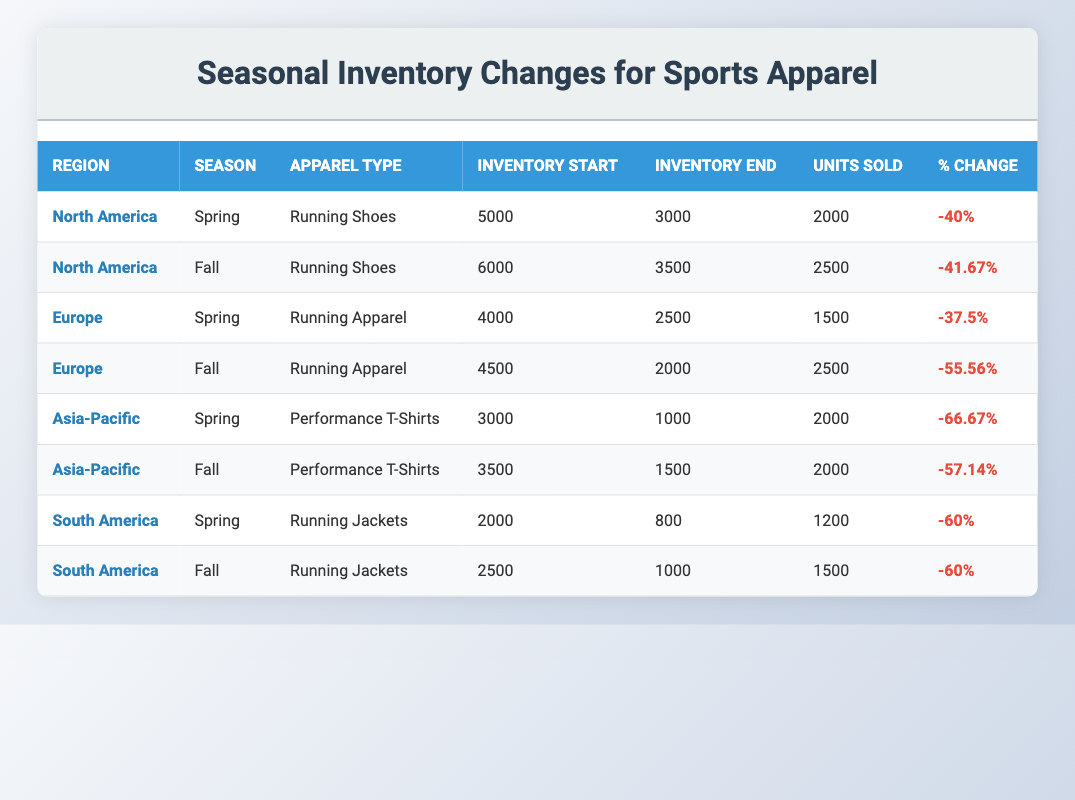What was the inventory start for Running Shoes in North America during Spring? The table lists the inventory start for Running Shoes in North America during Spring as 5000 units.
Answer: 5000 What is the percentage change for Running Apparel in Europe during Fall? According to the table, the percentage change for Running Apparel in Europe during Fall is -55.56%.
Answer: -55.56% In which region and season did Performance T-Shirts have the highest percentage change? By examining the table, Performance T-Shirts had the highest percentage change of -66.67% in the Asia-Pacific region during Spring.
Answer: Asia-Pacific, Spring What were the total units sold for Running Jackets in South America across both seasons? The units sold for Running Jackets were 1200 in Spring and 1500 in Fall. Adding these gives a total of 1200 + 1500 = 2700 units sold.
Answer: 2700 Was there an increase in inventory for any apparel type across the seasons listed? Upon reviewing the table, there are no instances of an increase in inventory for any apparel type; all entries show a decrease in inventory.
Answer: No What region had the most units sold for Running Shoes, and how many units were they? The table shows that North America had the most units sold for Running Shoes at 2500 units during Fall.
Answer: North America, 2500 What is the average inventory change percentage for Performance T-Shirts across both seasons? The percentage changes for Performance T-Shirts are -66.67% in Spring and -57.14% in Fall. The average is calculated as (-66.67 + -57.14) / 2 = -61.905%.
Answer: -61.91 Which apparel type had the least inventory left at the end of Spring? The table states that Performance T-Shirts in Asia-Pacific had the least inventory left at the end of Spring, with 1000 units remaining.
Answer: Performance T-Shirts In which season did Running Jackets in South America have the highest units sold? By analyzing the table, Running Jackets had the highest units sold in Fall with 1500 units, compared to 1200 units in Spring.
Answer: Fall 